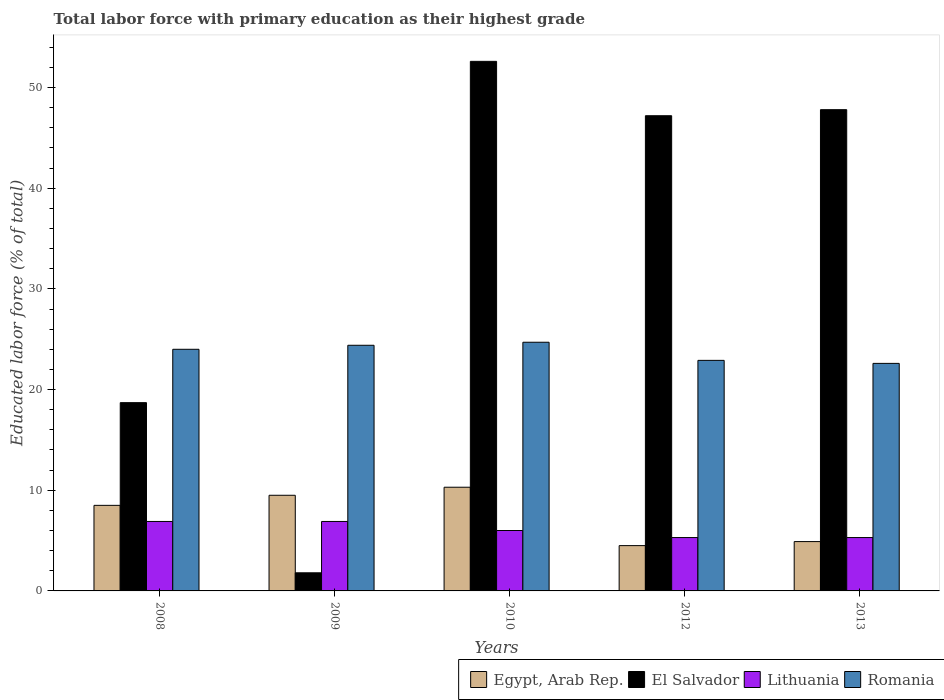How many different coloured bars are there?
Provide a short and direct response. 4. How many groups of bars are there?
Offer a terse response. 5. How many bars are there on the 2nd tick from the left?
Your answer should be very brief. 4. How many bars are there on the 2nd tick from the right?
Offer a very short reply. 4. What is the percentage of total labor force with primary education in El Salvador in 2012?
Give a very brief answer. 47.2. Across all years, what is the maximum percentage of total labor force with primary education in El Salvador?
Provide a succinct answer. 52.6. In which year was the percentage of total labor force with primary education in El Salvador maximum?
Your response must be concise. 2010. What is the total percentage of total labor force with primary education in Romania in the graph?
Provide a short and direct response. 118.6. What is the difference between the percentage of total labor force with primary education in Romania in 2008 and that in 2013?
Make the answer very short. 1.4. What is the difference between the percentage of total labor force with primary education in Lithuania in 2008 and the percentage of total labor force with primary education in Egypt, Arab Rep. in 2009?
Offer a very short reply. -2.6. What is the average percentage of total labor force with primary education in Lithuania per year?
Ensure brevity in your answer.  6.08. In the year 2009, what is the difference between the percentage of total labor force with primary education in Lithuania and percentage of total labor force with primary education in Romania?
Offer a very short reply. -17.5. What is the ratio of the percentage of total labor force with primary education in Egypt, Arab Rep. in 2012 to that in 2013?
Offer a very short reply. 0.92. What is the difference between the highest and the second highest percentage of total labor force with primary education in Romania?
Give a very brief answer. 0.3. What is the difference between the highest and the lowest percentage of total labor force with primary education in Egypt, Arab Rep.?
Your response must be concise. 5.8. Is the sum of the percentage of total labor force with primary education in Egypt, Arab Rep. in 2010 and 2013 greater than the maximum percentage of total labor force with primary education in El Salvador across all years?
Ensure brevity in your answer.  No. What does the 1st bar from the left in 2012 represents?
Keep it short and to the point. Egypt, Arab Rep. What does the 1st bar from the right in 2012 represents?
Your response must be concise. Romania. Are all the bars in the graph horizontal?
Give a very brief answer. No. How many years are there in the graph?
Ensure brevity in your answer.  5. What is the difference between two consecutive major ticks on the Y-axis?
Your answer should be compact. 10. Are the values on the major ticks of Y-axis written in scientific E-notation?
Provide a succinct answer. No. Does the graph contain any zero values?
Offer a terse response. No. Does the graph contain grids?
Provide a short and direct response. No. Where does the legend appear in the graph?
Offer a very short reply. Bottom right. How many legend labels are there?
Your answer should be very brief. 4. What is the title of the graph?
Ensure brevity in your answer.  Total labor force with primary education as their highest grade. Does "Kenya" appear as one of the legend labels in the graph?
Give a very brief answer. No. What is the label or title of the Y-axis?
Offer a very short reply. Educated labor force (% of total). What is the Educated labor force (% of total) of Egypt, Arab Rep. in 2008?
Your answer should be compact. 8.5. What is the Educated labor force (% of total) in El Salvador in 2008?
Give a very brief answer. 18.7. What is the Educated labor force (% of total) in Lithuania in 2008?
Make the answer very short. 6.9. What is the Educated labor force (% of total) of Romania in 2008?
Provide a short and direct response. 24. What is the Educated labor force (% of total) in El Salvador in 2009?
Provide a short and direct response. 1.8. What is the Educated labor force (% of total) of Lithuania in 2009?
Make the answer very short. 6.9. What is the Educated labor force (% of total) in Romania in 2009?
Provide a succinct answer. 24.4. What is the Educated labor force (% of total) in Egypt, Arab Rep. in 2010?
Give a very brief answer. 10.3. What is the Educated labor force (% of total) of El Salvador in 2010?
Offer a very short reply. 52.6. What is the Educated labor force (% of total) in Lithuania in 2010?
Ensure brevity in your answer.  6. What is the Educated labor force (% of total) of Romania in 2010?
Give a very brief answer. 24.7. What is the Educated labor force (% of total) of Egypt, Arab Rep. in 2012?
Your answer should be very brief. 4.5. What is the Educated labor force (% of total) of El Salvador in 2012?
Offer a terse response. 47.2. What is the Educated labor force (% of total) of Lithuania in 2012?
Provide a short and direct response. 5.3. What is the Educated labor force (% of total) in Romania in 2012?
Your answer should be compact. 22.9. What is the Educated labor force (% of total) of Egypt, Arab Rep. in 2013?
Provide a short and direct response. 4.9. What is the Educated labor force (% of total) of El Salvador in 2013?
Keep it short and to the point. 47.8. What is the Educated labor force (% of total) in Lithuania in 2013?
Your answer should be very brief. 5.3. What is the Educated labor force (% of total) in Romania in 2013?
Your answer should be compact. 22.6. Across all years, what is the maximum Educated labor force (% of total) of Egypt, Arab Rep.?
Offer a terse response. 10.3. Across all years, what is the maximum Educated labor force (% of total) in El Salvador?
Your answer should be very brief. 52.6. Across all years, what is the maximum Educated labor force (% of total) in Lithuania?
Provide a succinct answer. 6.9. Across all years, what is the maximum Educated labor force (% of total) of Romania?
Provide a succinct answer. 24.7. Across all years, what is the minimum Educated labor force (% of total) of El Salvador?
Offer a very short reply. 1.8. Across all years, what is the minimum Educated labor force (% of total) of Lithuania?
Offer a terse response. 5.3. Across all years, what is the minimum Educated labor force (% of total) of Romania?
Keep it short and to the point. 22.6. What is the total Educated labor force (% of total) of Egypt, Arab Rep. in the graph?
Your answer should be compact. 37.7. What is the total Educated labor force (% of total) in El Salvador in the graph?
Give a very brief answer. 168.1. What is the total Educated labor force (% of total) in Lithuania in the graph?
Give a very brief answer. 30.4. What is the total Educated labor force (% of total) in Romania in the graph?
Your answer should be very brief. 118.6. What is the difference between the Educated labor force (% of total) of Egypt, Arab Rep. in 2008 and that in 2009?
Offer a very short reply. -1. What is the difference between the Educated labor force (% of total) of Romania in 2008 and that in 2009?
Ensure brevity in your answer.  -0.4. What is the difference between the Educated labor force (% of total) of El Salvador in 2008 and that in 2010?
Make the answer very short. -33.9. What is the difference between the Educated labor force (% of total) of Romania in 2008 and that in 2010?
Make the answer very short. -0.7. What is the difference between the Educated labor force (% of total) of Egypt, Arab Rep. in 2008 and that in 2012?
Offer a very short reply. 4. What is the difference between the Educated labor force (% of total) in El Salvador in 2008 and that in 2012?
Give a very brief answer. -28.5. What is the difference between the Educated labor force (% of total) in Lithuania in 2008 and that in 2012?
Offer a very short reply. 1.6. What is the difference between the Educated labor force (% of total) of Romania in 2008 and that in 2012?
Your response must be concise. 1.1. What is the difference between the Educated labor force (% of total) in Egypt, Arab Rep. in 2008 and that in 2013?
Offer a terse response. 3.6. What is the difference between the Educated labor force (% of total) in El Salvador in 2008 and that in 2013?
Give a very brief answer. -29.1. What is the difference between the Educated labor force (% of total) of Lithuania in 2008 and that in 2013?
Offer a terse response. 1.6. What is the difference between the Educated labor force (% of total) of Romania in 2008 and that in 2013?
Offer a terse response. 1.4. What is the difference between the Educated labor force (% of total) in El Salvador in 2009 and that in 2010?
Offer a very short reply. -50.8. What is the difference between the Educated labor force (% of total) of Egypt, Arab Rep. in 2009 and that in 2012?
Your answer should be very brief. 5. What is the difference between the Educated labor force (% of total) in El Salvador in 2009 and that in 2012?
Offer a very short reply. -45.4. What is the difference between the Educated labor force (% of total) of Lithuania in 2009 and that in 2012?
Provide a succinct answer. 1.6. What is the difference between the Educated labor force (% of total) in Romania in 2009 and that in 2012?
Your response must be concise. 1.5. What is the difference between the Educated labor force (% of total) in Egypt, Arab Rep. in 2009 and that in 2013?
Offer a terse response. 4.6. What is the difference between the Educated labor force (% of total) of El Salvador in 2009 and that in 2013?
Your answer should be compact. -46. What is the difference between the Educated labor force (% of total) in Romania in 2009 and that in 2013?
Ensure brevity in your answer.  1.8. What is the difference between the Educated labor force (% of total) in Egypt, Arab Rep. in 2010 and that in 2012?
Keep it short and to the point. 5.8. What is the difference between the Educated labor force (% of total) in El Salvador in 2010 and that in 2012?
Keep it short and to the point. 5.4. What is the difference between the Educated labor force (% of total) of Lithuania in 2010 and that in 2012?
Provide a short and direct response. 0.7. What is the difference between the Educated labor force (% of total) in Lithuania in 2010 and that in 2013?
Make the answer very short. 0.7. What is the difference between the Educated labor force (% of total) of El Salvador in 2012 and that in 2013?
Keep it short and to the point. -0.6. What is the difference between the Educated labor force (% of total) of Lithuania in 2012 and that in 2013?
Your answer should be very brief. 0. What is the difference between the Educated labor force (% of total) in Egypt, Arab Rep. in 2008 and the Educated labor force (% of total) in Lithuania in 2009?
Provide a short and direct response. 1.6. What is the difference between the Educated labor force (% of total) in Egypt, Arab Rep. in 2008 and the Educated labor force (% of total) in Romania in 2009?
Offer a terse response. -15.9. What is the difference between the Educated labor force (% of total) in El Salvador in 2008 and the Educated labor force (% of total) in Lithuania in 2009?
Keep it short and to the point. 11.8. What is the difference between the Educated labor force (% of total) in Lithuania in 2008 and the Educated labor force (% of total) in Romania in 2009?
Offer a very short reply. -17.5. What is the difference between the Educated labor force (% of total) of Egypt, Arab Rep. in 2008 and the Educated labor force (% of total) of El Salvador in 2010?
Provide a short and direct response. -44.1. What is the difference between the Educated labor force (% of total) of Egypt, Arab Rep. in 2008 and the Educated labor force (% of total) of Lithuania in 2010?
Offer a very short reply. 2.5. What is the difference between the Educated labor force (% of total) in Egypt, Arab Rep. in 2008 and the Educated labor force (% of total) in Romania in 2010?
Provide a succinct answer. -16.2. What is the difference between the Educated labor force (% of total) in El Salvador in 2008 and the Educated labor force (% of total) in Lithuania in 2010?
Provide a short and direct response. 12.7. What is the difference between the Educated labor force (% of total) in Lithuania in 2008 and the Educated labor force (% of total) in Romania in 2010?
Your answer should be very brief. -17.8. What is the difference between the Educated labor force (% of total) of Egypt, Arab Rep. in 2008 and the Educated labor force (% of total) of El Salvador in 2012?
Your response must be concise. -38.7. What is the difference between the Educated labor force (% of total) of Egypt, Arab Rep. in 2008 and the Educated labor force (% of total) of Romania in 2012?
Your answer should be very brief. -14.4. What is the difference between the Educated labor force (% of total) in El Salvador in 2008 and the Educated labor force (% of total) in Lithuania in 2012?
Give a very brief answer. 13.4. What is the difference between the Educated labor force (% of total) in El Salvador in 2008 and the Educated labor force (% of total) in Romania in 2012?
Your response must be concise. -4.2. What is the difference between the Educated labor force (% of total) in Egypt, Arab Rep. in 2008 and the Educated labor force (% of total) in El Salvador in 2013?
Offer a terse response. -39.3. What is the difference between the Educated labor force (% of total) in Egypt, Arab Rep. in 2008 and the Educated labor force (% of total) in Romania in 2013?
Keep it short and to the point. -14.1. What is the difference between the Educated labor force (% of total) of El Salvador in 2008 and the Educated labor force (% of total) of Romania in 2013?
Ensure brevity in your answer.  -3.9. What is the difference between the Educated labor force (% of total) of Lithuania in 2008 and the Educated labor force (% of total) of Romania in 2013?
Offer a terse response. -15.7. What is the difference between the Educated labor force (% of total) of Egypt, Arab Rep. in 2009 and the Educated labor force (% of total) of El Salvador in 2010?
Your response must be concise. -43.1. What is the difference between the Educated labor force (% of total) of Egypt, Arab Rep. in 2009 and the Educated labor force (% of total) of Lithuania in 2010?
Offer a terse response. 3.5. What is the difference between the Educated labor force (% of total) of Egypt, Arab Rep. in 2009 and the Educated labor force (% of total) of Romania in 2010?
Your answer should be very brief. -15.2. What is the difference between the Educated labor force (% of total) of El Salvador in 2009 and the Educated labor force (% of total) of Romania in 2010?
Give a very brief answer. -22.9. What is the difference between the Educated labor force (% of total) in Lithuania in 2009 and the Educated labor force (% of total) in Romania in 2010?
Your response must be concise. -17.8. What is the difference between the Educated labor force (% of total) in Egypt, Arab Rep. in 2009 and the Educated labor force (% of total) in El Salvador in 2012?
Ensure brevity in your answer.  -37.7. What is the difference between the Educated labor force (% of total) in Egypt, Arab Rep. in 2009 and the Educated labor force (% of total) in Lithuania in 2012?
Provide a short and direct response. 4.2. What is the difference between the Educated labor force (% of total) in Egypt, Arab Rep. in 2009 and the Educated labor force (% of total) in Romania in 2012?
Provide a short and direct response. -13.4. What is the difference between the Educated labor force (% of total) of El Salvador in 2009 and the Educated labor force (% of total) of Romania in 2012?
Your answer should be very brief. -21.1. What is the difference between the Educated labor force (% of total) in Egypt, Arab Rep. in 2009 and the Educated labor force (% of total) in El Salvador in 2013?
Keep it short and to the point. -38.3. What is the difference between the Educated labor force (% of total) of Egypt, Arab Rep. in 2009 and the Educated labor force (% of total) of Romania in 2013?
Your answer should be compact. -13.1. What is the difference between the Educated labor force (% of total) in El Salvador in 2009 and the Educated labor force (% of total) in Romania in 2013?
Your response must be concise. -20.8. What is the difference between the Educated labor force (% of total) in Lithuania in 2009 and the Educated labor force (% of total) in Romania in 2013?
Keep it short and to the point. -15.7. What is the difference between the Educated labor force (% of total) in Egypt, Arab Rep. in 2010 and the Educated labor force (% of total) in El Salvador in 2012?
Give a very brief answer. -36.9. What is the difference between the Educated labor force (% of total) in Egypt, Arab Rep. in 2010 and the Educated labor force (% of total) in Romania in 2012?
Give a very brief answer. -12.6. What is the difference between the Educated labor force (% of total) of El Salvador in 2010 and the Educated labor force (% of total) of Lithuania in 2012?
Give a very brief answer. 47.3. What is the difference between the Educated labor force (% of total) of El Salvador in 2010 and the Educated labor force (% of total) of Romania in 2012?
Provide a succinct answer. 29.7. What is the difference between the Educated labor force (% of total) in Lithuania in 2010 and the Educated labor force (% of total) in Romania in 2012?
Your answer should be very brief. -16.9. What is the difference between the Educated labor force (% of total) in Egypt, Arab Rep. in 2010 and the Educated labor force (% of total) in El Salvador in 2013?
Offer a very short reply. -37.5. What is the difference between the Educated labor force (% of total) in Egypt, Arab Rep. in 2010 and the Educated labor force (% of total) in Romania in 2013?
Give a very brief answer. -12.3. What is the difference between the Educated labor force (% of total) of El Salvador in 2010 and the Educated labor force (% of total) of Lithuania in 2013?
Give a very brief answer. 47.3. What is the difference between the Educated labor force (% of total) of El Salvador in 2010 and the Educated labor force (% of total) of Romania in 2013?
Give a very brief answer. 30. What is the difference between the Educated labor force (% of total) of Lithuania in 2010 and the Educated labor force (% of total) of Romania in 2013?
Provide a succinct answer. -16.6. What is the difference between the Educated labor force (% of total) of Egypt, Arab Rep. in 2012 and the Educated labor force (% of total) of El Salvador in 2013?
Provide a short and direct response. -43.3. What is the difference between the Educated labor force (% of total) in Egypt, Arab Rep. in 2012 and the Educated labor force (% of total) in Lithuania in 2013?
Provide a succinct answer. -0.8. What is the difference between the Educated labor force (% of total) of Egypt, Arab Rep. in 2012 and the Educated labor force (% of total) of Romania in 2013?
Provide a short and direct response. -18.1. What is the difference between the Educated labor force (% of total) of El Salvador in 2012 and the Educated labor force (% of total) of Lithuania in 2013?
Ensure brevity in your answer.  41.9. What is the difference between the Educated labor force (% of total) in El Salvador in 2012 and the Educated labor force (% of total) in Romania in 2013?
Provide a short and direct response. 24.6. What is the difference between the Educated labor force (% of total) in Lithuania in 2012 and the Educated labor force (% of total) in Romania in 2013?
Offer a very short reply. -17.3. What is the average Educated labor force (% of total) in Egypt, Arab Rep. per year?
Your response must be concise. 7.54. What is the average Educated labor force (% of total) in El Salvador per year?
Make the answer very short. 33.62. What is the average Educated labor force (% of total) of Lithuania per year?
Give a very brief answer. 6.08. What is the average Educated labor force (% of total) of Romania per year?
Make the answer very short. 23.72. In the year 2008, what is the difference between the Educated labor force (% of total) of Egypt, Arab Rep. and Educated labor force (% of total) of El Salvador?
Make the answer very short. -10.2. In the year 2008, what is the difference between the Educated labor force (% of total) of Egypt, Arab Rep. and Educated labor force (% of total) of Lithuania?
Your response must be concise. 1.6. In the year 2008, what is the difference between the Educated labor force (% of total) of Egypt, Arab Rep. and Educated labor force (% of total) of Romania?
Keep it short and to the point. -15.5. In the year 2008, what is the difference between the Educated labor force (% of total) of Lithuania and Educated labor force (% of total) of Romania?
Make the answer very short. -17.1. In the year 2009, what is the difference between the Educated labor force (% of total) in Egypt, Arab Rep. and Educated labor force (% of total) in Romania?
Provide a short and direct response. -14.9. In the year 2009, what is the difference between the Educated labor force (% of total) in El Salvador and Educated labor force (% of total) in Lithuania?
Offer a very short reply. -5.1. In the year 2009, what is the difference between the Educated labor force (% of total) in El Salvador and Educated labor force (% of total) in Romania?
Provide a short and direct response. -22.6. In the year 2009, what is the difference between the Educated labor force (% of total) in Lithuania and Educated labor force (% of total) in Romania?
Offer a very short reply. -17.5. In the year 2010, what is the difference between the Educated labor force (% of total) of Egypt, Arab Rep. and Educated labor force (% of total) of El Salvador?
Provide a short and direct response. -42.3. In the year 2010, what is the difference between the Educated labor force (% of total) in Egypt, Arab Rep. and Educated labor force (% of total) in Lithuania?
Offer a terse response. 4.3. In the year 2010, what is the difference between the Educated labor force (% of total) in Egypt, Arab Rep. and Educated labor force (% of total) in Romania?
Your answer should be compact. -14.4. In the year 2010, what is the difference between the Educated labor force (% of total) in El Salvador and Educated labor force (% of total) in Lithuania?
Provide a short and direct response. 46.6. In the year 2010, what is the difference between the Educated labor force (% of total) in El Salvador and Educated labor force (% of total) in Romania?
Offer a terse response. 27.9. In the year 2010, what is the difference between the Educated labor force (% of total) of Lithuania and Educated labor force (% of total) of Romania?
Offer a very short reply. -18.7. In the year 2012, what is the difference between the Educated labor force (% of total) of Egypt, Arab Rep. and Educated labor force (% of total) of El Salvador?
Provide a succinct answer. -42.7. In the year 2012, what is the difference between the Educated labor force (% of total) of Egypt, Arab Rep. and Educated labor force (% of total) of Romania?
Give a very brief answer. -18.4. In the year 2012, what is the difference between the Educated labor force (% of total) of El Salvador and Educated labor force (% of total) of Lithuania?
Ensure brevity in your answer.  41.9. In the year 2012, what is the difference between the Educated labor force (% of total) of El Salvador and Educated labor force (% of total) of Romania?
Make the answer very short. 24.3. In the year 2012, what is the difference between the Educated labor force (% of total) of Lithuania and Educated labor force (% of total) of Romania?
Make the answer very short. -17.6. In the year 2013, what is the difference between the Educated labor force (% of total) of Egypt, Arab Rep. and Educated labor force (% of total) of El Salvador?
Your response must be concise. -42.9. In the year 2013, what is the difference between the Educated labor force (% of total) of Egypt, Arab Rep. and Educated labor force (% of total) of Lithuania?
Your answer should be very brief. -0.4. In the year 2013, what is the difference between the Educated labor force (% of total) of Egypt, Arab Rep. and Educated labor force (% of total) of Romania?
Your response must be concise. -17.7. In the year 2013, what is the difference between the Educated labor force (% of total) of El Salvador and Educated labor force (% of total) of Lithuania?
Your answer should be very brief. 42.5. In the year 2013, what is the difference between the Educated labor force (% of total) of El Salvador and Educated labor force (% of total) of Romania?
Your answer should be compact. 25.2. In the year 2013, what is the difference between the Educated labor force (% of total) of Lithuania and Educated labor force (% of total) of Romania?
Keep it short and to the point. -17.3. What is the ratio of the Educated labor force (% of total) of Egypt, Arab Rep. in 2008 to that in 2009?
Keep it short and to the point. 0.89. What is the ratio of the Educated labor force (% of total) in El Salvador in 2008 to that in 2009?
Ensure brevity in your answer.  10.39. What is the ratio of the Educated labor force (% of total) of Romania in 2008 to that in 2009?
Ensure brevity in your answer.  0.98. What is the ratio of the Educated labor force (% of total) of Egypt, Arab Rep. in 2008 to that in 2010?
Keep it short and to the point. 0.83. What is the ratio of the Educated labor force (% of total) of El Salvador in 2008 to that in 2010?
Offer a terse response. 0.36. What is the ratio of the Educated labor force (% of total) of Lithuania in 2008 to that in 2010?
Provide a succinct answer. 1.15. What is the ratio of the Educated labor force (% of total) of Romania in 2008 to that in 2010?
Keep it short and to the point. 0.97. What is the ratio of the Educated labor force (% of total) of Egypt, Arab Rep. in 2008 to that in 2012?
Give a very brief answer. 1.89. What is the ratio of the Educated labor force (% of total) in El Salvador in 2008 to that in 2012?
Ensure brevity in your answer.  0.4. What is the ratio of the Educated labor force (% of total) in Lithuania in 2008 to that in 2012?
Provide a short and direct response. 1.3. What is the ratio of the Educated labor force (% of total) in Romania in 2008 to that in 2012?
Your response must be concise. 1.05. What is the ratio of the Educated labor force (% of total) in Egypt, Arab Rep. in 2008 to that in 2013?
Your response must be concise. 1.73. What is the ratio of the Educated labor force (% of total) in El Salvador in 2008 to that in 2013?
Give a very brief answer. 0.39. What is the ratio of the Educated labor force (% of total) of Lithuania in 2008 to that in 2013?
Offer a terse response. 1.3. What is the ratio of the Educated labor force (% of total) of Romania in 2008 to that in 2013?
Provide a short and direct response. 1.06. What is the ratio of the Educated labor force (% of total) of Egypt, Arab Rep. in 2009 to that in 2010?
Your response must be concise. 0.92. What is the ratio of the Educated labor force (% of total) in El Salvador in 2009 to that in 2010?
Ensure brevity in your answer.  0.03. What is the ratio of the Educated labor force (% of total) of Lithuania in 2009 to that in 2010?
Give a very brief answer. 1.15. What is the ratio of the Educated labor force (% of total) of Romania in 2009 to that in 2010?
Ensure brevity in your answer.  0.99. What is the ratio of the Educated labor force (% of total) in Egypt, Arab Rep. in 2009 to that in 2012?
Your answer should be very brief. 2.11. What is the ratio of the Educated labor force (% of total) of El Salvador in 2009 to that in 2012?
Provide a succinct answer. 0.04. What is the ratio of the Educated labor force (% of total) in Lithuania in 2009 to that in 2012?
Give a very brief answer. 1.3. What is the ratio of the Educated labor force (% of total) in Romania in 2009 to that in 2012?
Provide a succinct answer. 1.07. What is the ratio of the Educated labor force (% of total) of Egypt, Arab Rep. in 2009 to that in 2013?
Your answer should be compact. 1.94. What is the ratio of the Educated labor force (% of total) in El Salvador in 2009 to that in 2013?
Provide a short and direct response. 0.04. What is the ratio of the Educated labor force (% of total) in Lithuania in 2009 to that in 2013?
Provide a succinct answer. 1.3. What is the ratio of the Educated labor force (% of total) of Romania in 2009 to that in 2013?
Your answer should be very brief. 1.08. What is the ratio of the Educated labor force (% of total) in Egypt, Arab Rep. in 2010 to that in 2012?
Provide a succinct answer. 2.29. What is the ratio of the Educated labor force (% of total) in El Salvador in 2010 to that in 2012?
Offer a very short reply. 1.11. What is the ratio of the Educated labor force (% of total) in Lithuania in 2010 to that in 2012?
Provide a short and direct response. 1.13. What is the ratio of the Educated labor force (% of total) of Romania in 2010 to that in 2012?
Offer a very short reply. 1.08. What is the ratio of the Educated labor force (% of total) of Egypt, Arab Rep. in 2010 to that in 2013?
Offer a terse response. 2.1. What is the ratio of the Educated labor force (% of total) of El Salvador in 2010 to that in 2013?
Make the answer very short. 1.1. What is the ratio of the Educated labor force (% of total) of Lithuania in 2010 to that in 2013?
Ensure brevity in your answer.  1.13. What is the ratio of the Educated labor force (% of total) of Romania in 2010 to that in 2013?
Ensure brevity in your answer.  1.09. What is the ratio of the Educated labor force (% of total) of Egypt, Arab Rep. in 2012 to that in 2013?
Give a very brief answer. 0.92. What is the ratio of the Educated labor force (% of total) of El Salvador in 2012 to that in 2013?
Keep it short and to the point. 0.99. What is the ratio of the Educated labor force (% of total) of Lithuania in 2012 to that in 2013?
Provide a succinct answer. 1. What is the ratio of the Educated labor force (% of total) in Romania in 2012 to that in 2013?
Offer a terse response. 1.01. What is the difference between the highest and the second highest Educated labor force (% of total) in Egypt, Arab Rep.?
Your response must be concise. 0.8. What is the difference between the highest and the second highest Educated labor force (% of total) of El Salvador?
Offer a very short reply. 4.8. What is the difference between the highest and the lowest Educated labor force (% of total) in Egypt, Arab Rep.?
Offer a very short reply. 5.8. What is the difference between the highest and the lowest Educated labor force (% of total) of El Salvador?
Make the answer very short. 50.8. 